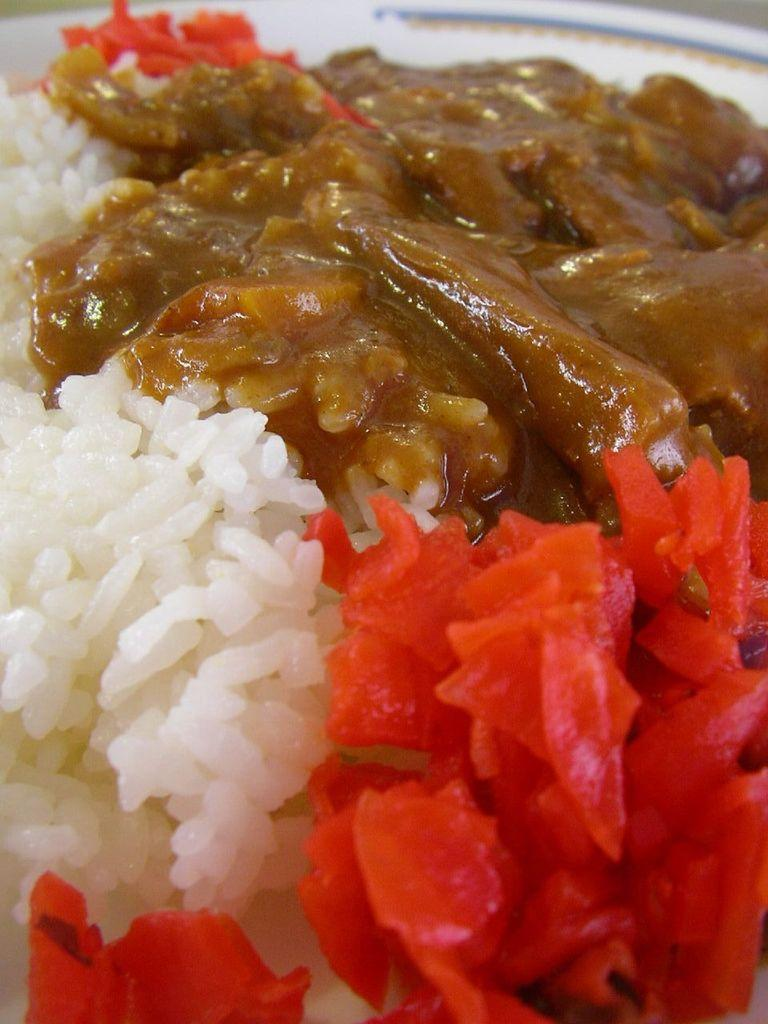What is the main subject of the image? There is a food item in the image. How is the food item presented in the image? The food item is in a plate. Can you tell me how many horses are depicted in the image? There are no horses present in the image; it features a food item in a plate. What type of sail can be seen in the image? There is no sail present in the image; it only contains a food item in a plate. 